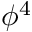<formula> <loc_0><loc_0><loc_500><loc_500>\phi ^ { 4 }</formula> 